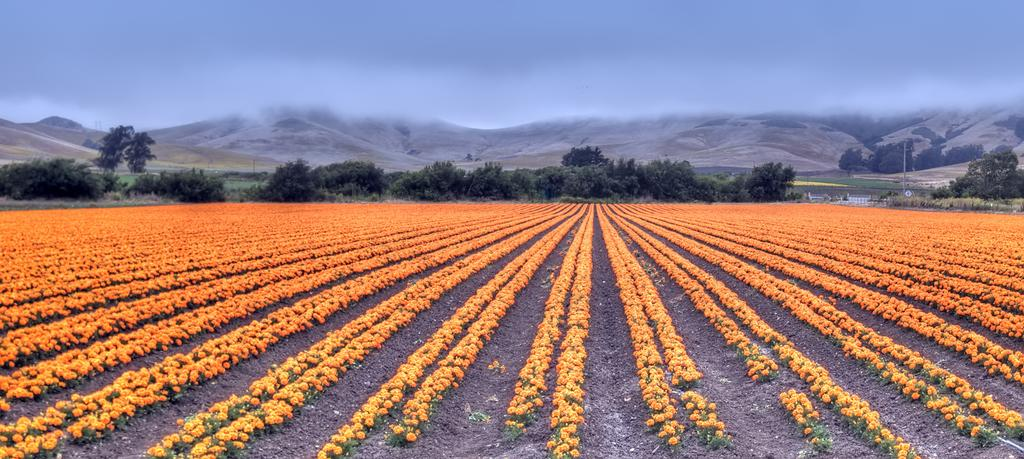What type of vegetation can be seen in the image? There is a group of flowers and a group of plants in the image. What can be seen in the background of the image? There are trees and mountains visible in the background of the image. What is visible at the top of the image? The sky is visible at the top of the image. What type of jeans is the needle sewing in the image? There is no mention of jeans or a needle in the image; it features a group of flowers, plants, trees, mountains, and the sky. 